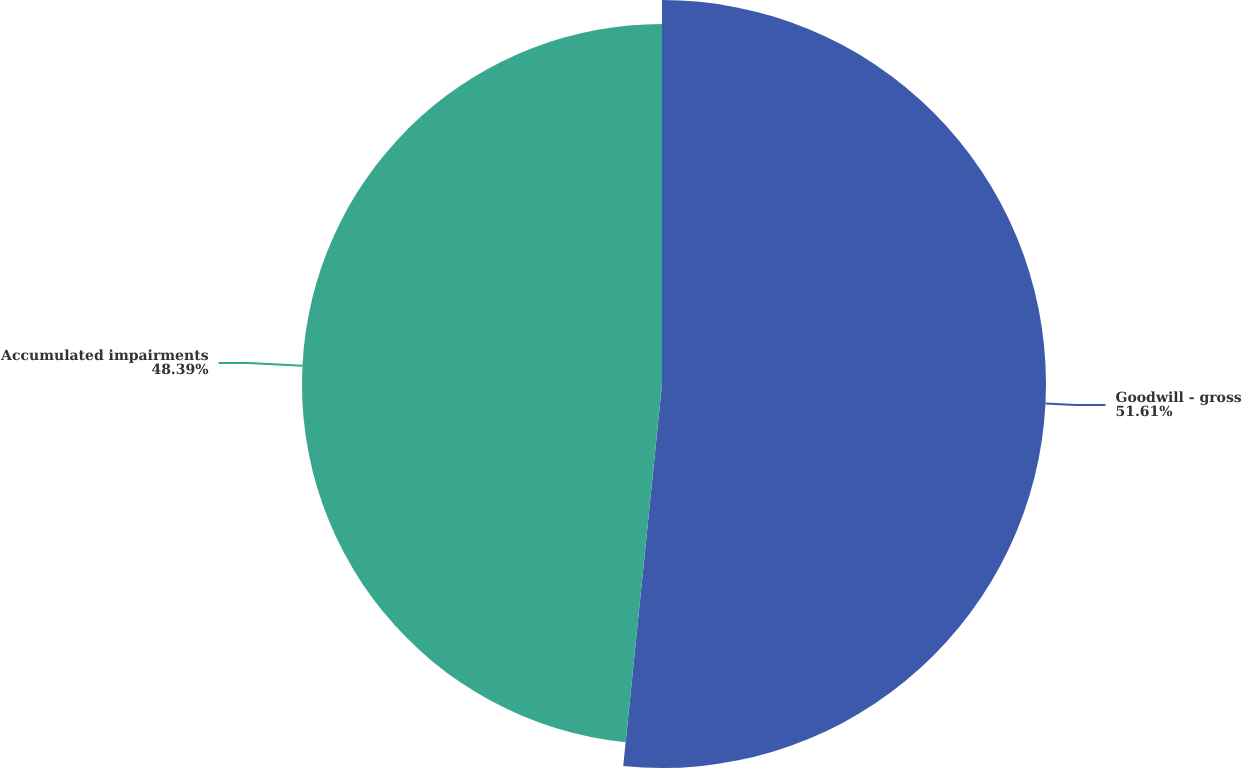<chart> <loc_0><loc_0><loc_500><loc_500><pie_chart><fcel>Goodwill - gross<fcel>Accumulated impairments<nl><fcel>51.61%<fcel>48.39%<nl></chart> 